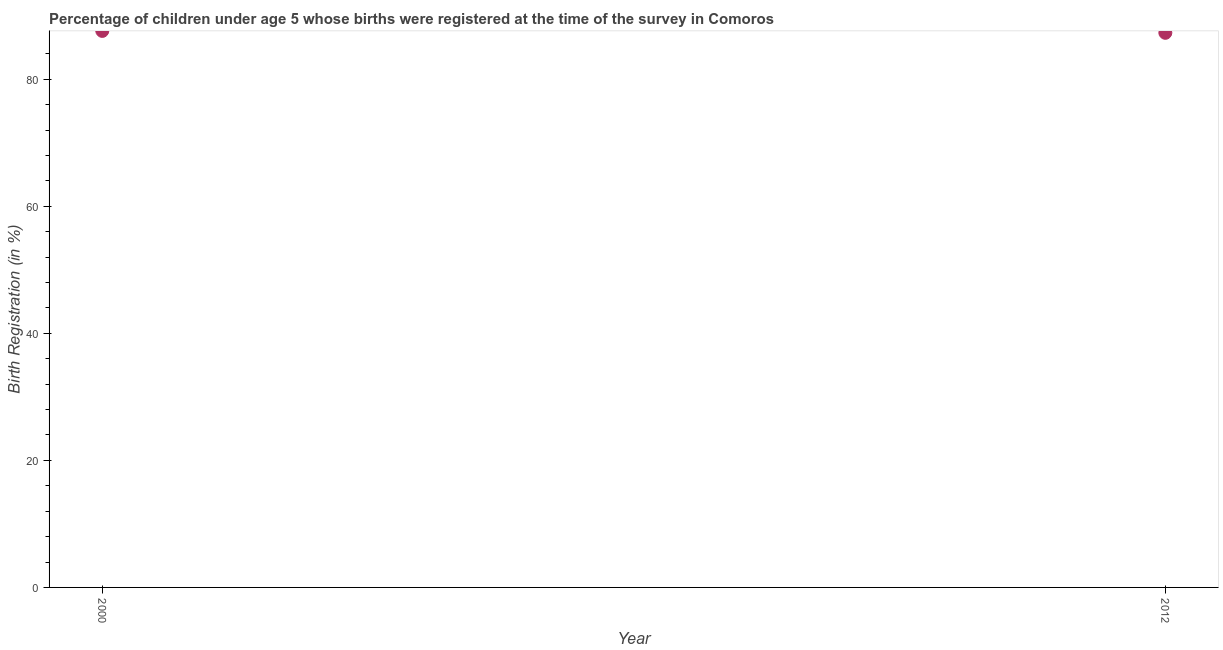What is the birth registration in 2012?
Offer a very short reply. 87.3. Across all years, what is the maximum birth registration?
Your answer should be very brief. 87.6. Across all years, what is the minimum birth registration?
Provide a short and direct response. 87.3. What is the sum of the birth registration?
Your answer should be compact. 174.9. What is the difference between the birth registration in 2000 and 2012?
Offer a terse response. 0.3. What is the average birth registration per year?
Make the answer very short. 87.45. What is the median birth registration?
Offer a very short reply. 87.45. In how many years, is the birth registration greater than 52 %?
Your response must be concise. 2. Do a majority of the years between 2012 and 2000 (inclusive) have birth registration greater than 64 %?
Give a very brief answer. No. What is the ratio of the birth registration in 2000 to that in 2012?
Your response must be concise. 1. Does the birth registration monotonically increase over the years?
Give a very brief answer. No. Does the graph contain grids?
Offer a terse response. No. What is the title of the graph?
Your answer should be very brief. Percentage of children under age 5 whose births were registered at the time of the survey in Comoros. What is the label or title of the Y-axis?
Make the answer very short. Birth Registration (in %). What is the Birth Registration (in %) in 2000?
Ensure brevity in your answer.  87.6. What is the Birth Registration (in %) in 2012?
Your answer should be compact. 87.3. What is the difference between the Birth Registration (in %) in 2000 and 2012?
Provide a short and direct response. 0.3. 